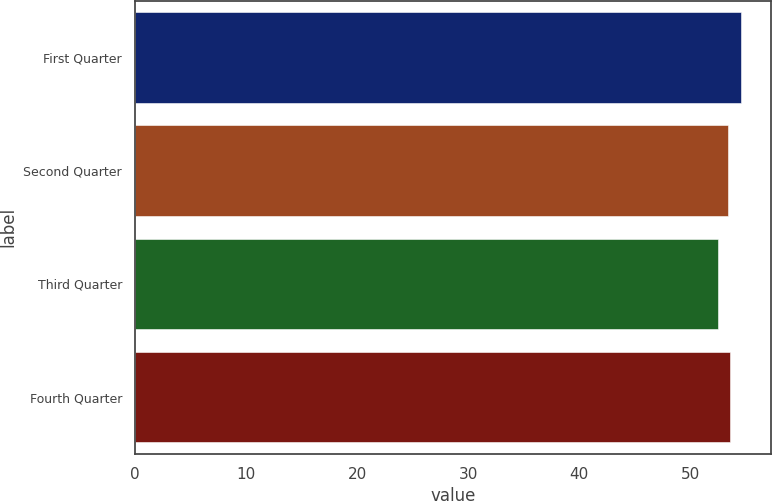<chart> <loc_0><loc_0><loc_500><loc_500><bar_chart><fcel>First Quarter<fcel>Second Quarter<fcel>Third Quarter<fcel>Fourth Quarter<nl><fcel>54.55<fcel>53.39<fcel>52.5<fcel>53.59<nl></chart> 